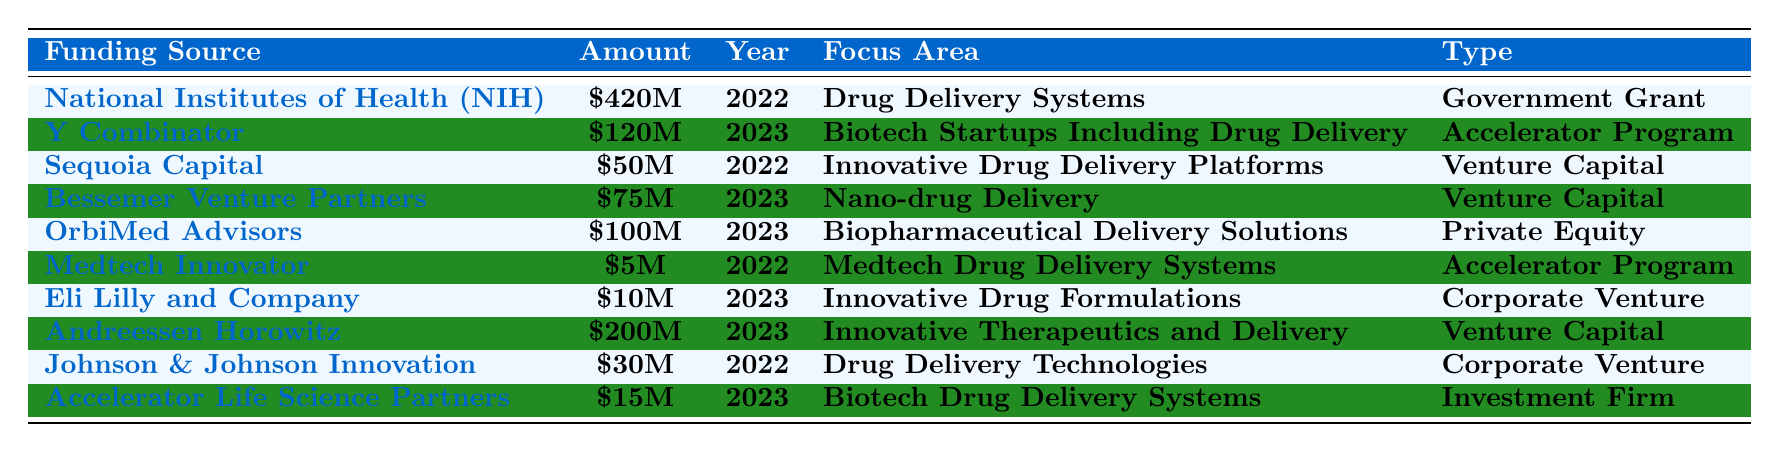What is the total funding amount from government sources in 2022? The only government source listed in 2022 is the National Institutes of Health (NIH), which provided $420 million. Therefore, the total funding amount from government sources in 2022 is simply $420 million.
Answer: $420 million Who provided the highest funding amount in 2023 for drug delivery innovations? In 2023, Andreessen Horowitz provided the highest amount, $200 million, specifically for innovative therapeutics and delivery.
Answer: $200 million Is the funding from Y Combinator for drug delivery systems? Y Combinator provided funding in 2023 for biotech startups including drug delivery, which means its focus area includes drug delivery systems. Thus, the answer is yes.
Answer: Yes What is the average funding amount across all sources in 2023? The total funding amounts for 2023 are $120 million (Y Combinator) + $75 million (Bessemer Venture Partners) + $100 million (OrbiMed Advisors) + $10 million (Eli Lilly) + $200 million (Andreessen Horowitz) + $15 million (Accelerator Life Science Partners) = $620 million. There are 6 sources, so average is $620/6 = $103.33 million.
Answer: $103.33 million Which funding source provided the least amount in 2022? In 2022, the Medtech Innovator provided the least amount, which is $5 million, compared to the NIH's $420 million and Sequoia Capital's $50 million.
Answer: $5 million How much more funding did Andreessen Horowitz provide than Eli Lilly in 2023? In 2023, Andreessen Horowitz provided $200 million, while Eli Lilly provided $10 million. The difference is $200 million - $10 million = $190 million.
Answer: $190 million Was there any corporate venture funding in 2022? Johnson & Johnson Innovation provided funding of $30 million in 2022, which is categorized as corporate venture funding. Therefore, the answer is yes.
Answer: Yes What is the total funding received by private equity sources across the years? OrbiMed Advisors is the only private equity source listed, and it provided $100 million in 2023. Thus, the total funding received by private equity sources is $100 million.
Answer: $100 million What percentage of the total funding in 2022 is from government grants? The total funding in 2022 is $420 million (NIH) + $50 million (Sequoia Capital) + $5 million (Medtech Innovator) + $30 million (Johnson & Johnson) = $505 million. The percentage from government grants is ($420 million / $505 million) * 100 = 83.07%.
Answer: 83.07% Which focus area had the highest number of funding sources in 2023? In 2023, the focus areas were "Biotech Startups Including Drug Delivery," "Nano-drug Delivery," "Biopharmaceutical Delivery Solutions," "Innovative Drug Formulations," "Innovative Therapeutics and Delivery," and "Biotech Drug Delivery Systems." There were six different focus areas, but only two sources specifically mention drug delivery. Both Y Combinator and Bessemer Venture Partners are relevant to drug delivery. Thus, the highest is related to drug delivery with two sources.
Answer: 2 sources 